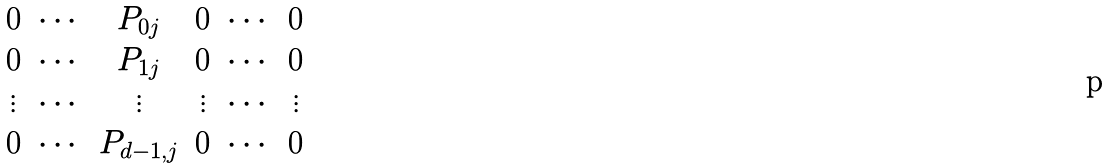Convert formula to latex. <formula><loc_0><loc_0><loc_500><loc_500>\begin{matrix} 0 & \cdots & { P } _ { 0 j } & 0 & \cdots & 0 \\ 0 & \cdots & { P } _ { 1 j } & 0 & \cdots & 0 \\ \vdots & \cdots & \vdots & \vdots & \cdots & \vdots \\ 0 & \cdots & { P } _ { d - 1 , j } & 0 & \cdots & 0 \end{matrix}</formula> 